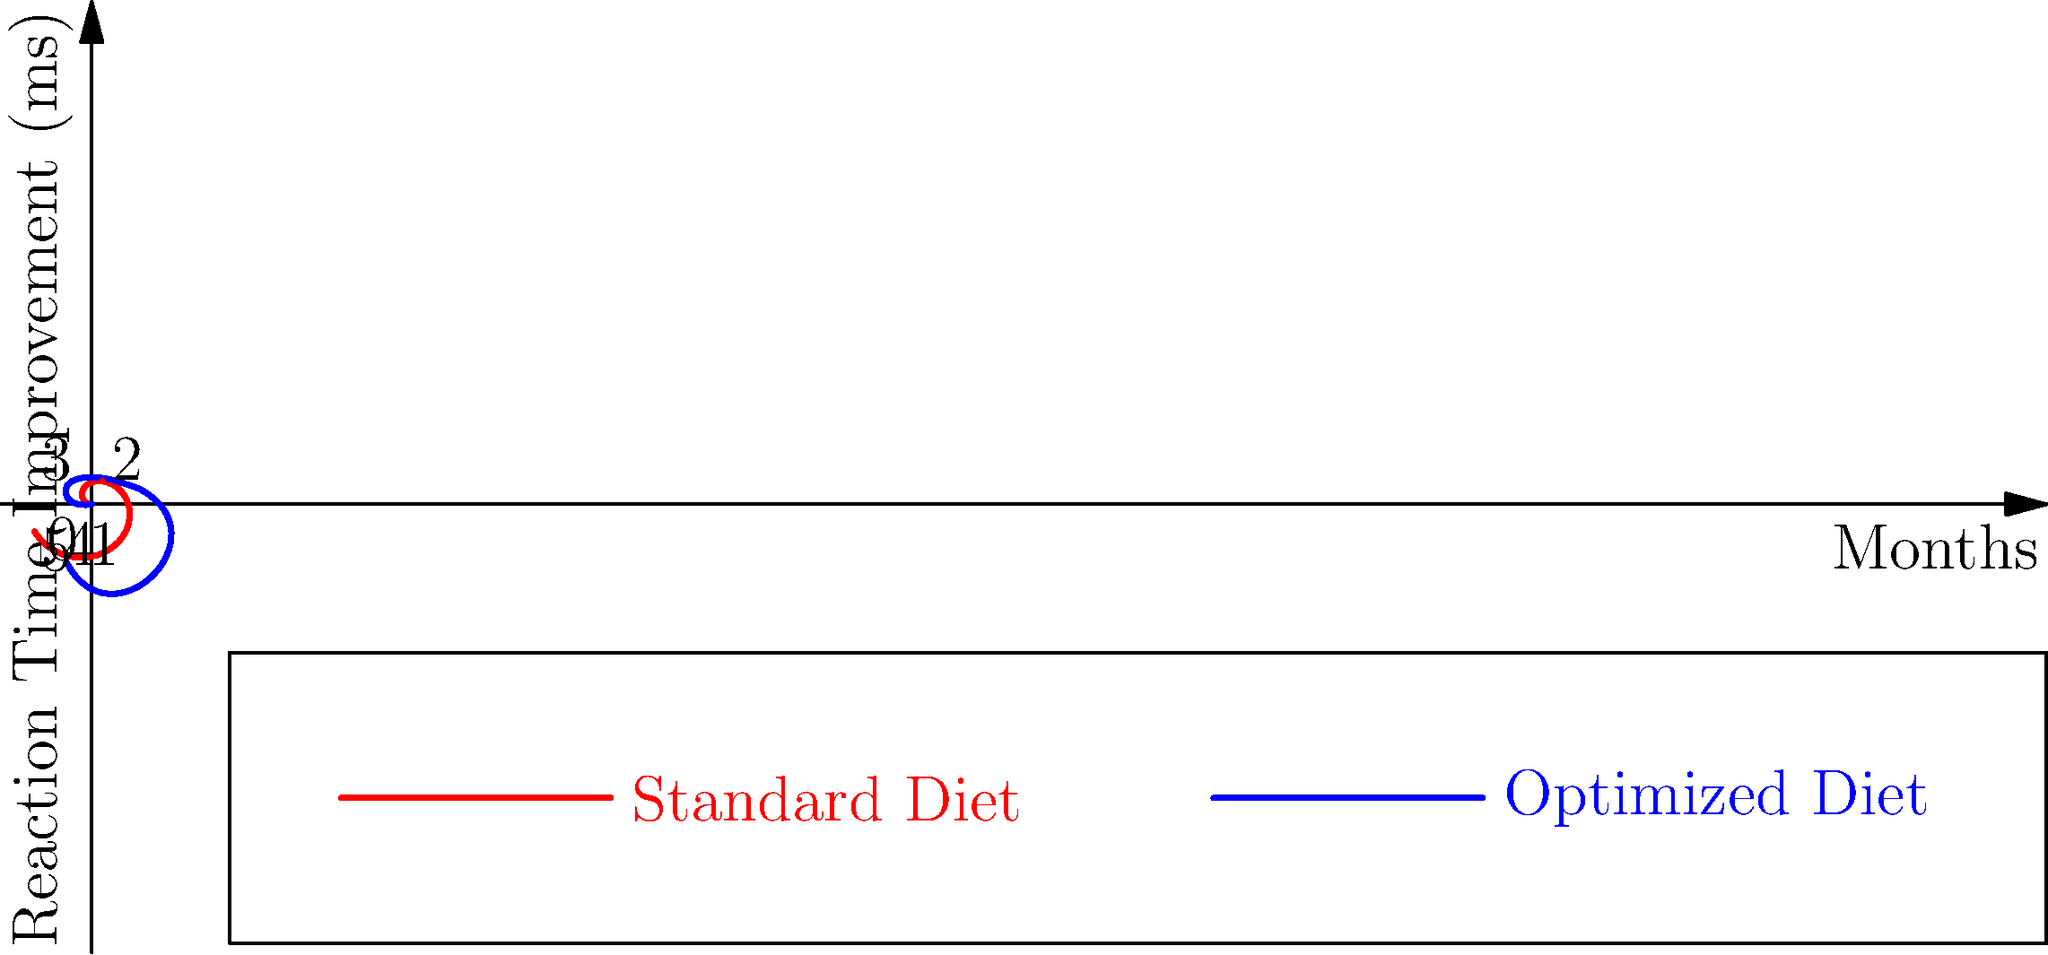The polar coordinate graph shows reaction time improvements (in milliseconds) over a 6-month period for two different diets: a standard diet (red) and an optimized diet (blue) for esports players. What is the total improvement in reaction time for the optimized diet from month 0 to month 6? To find the total improvement in reaction time for the optimized diet, we need to:

1. Identify the starting point (month 0) and endpoint (month 6) values for the optimized diet (blue line).
2. Calculate the difference between these two values.

Step-by-step:

1. Month 0 value (starting point):
   From the graph, we can see that the blue line starts at 15 ms.

2. Month 6 value (endpoint):
   The graph is circular, so month 6 corresponds to the same point as month 0.
   From the graph, we can see that the blue line ends at 42 ms.

3. Calculate the improvement:
   Improvement = Endpoint value - Starting point value
   $$ 42 \text{ ms} - 15 \text{ ms} = 27 \text{ ms} $$

Therefore, the total improvement in reaction time for the optimized diet from month 0 to month 6 is 27 ms.
Answer: 27 ms 